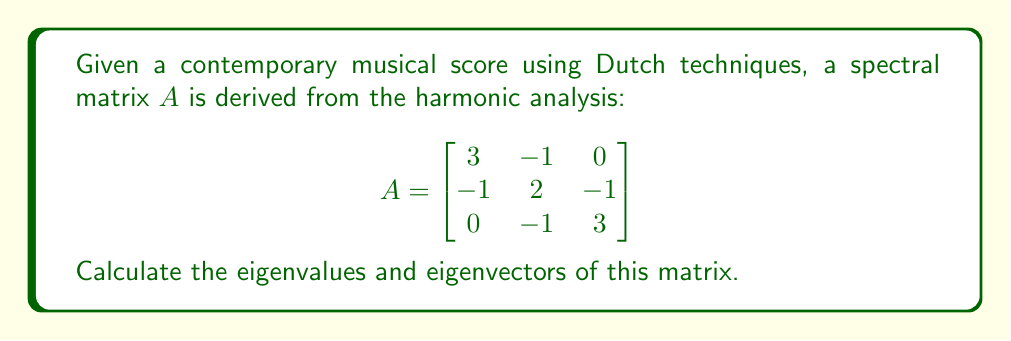Give your solution to this math problem. To find the eigenvalues and eigenvectors of matrix $A$, we follow these steps:

1. Find the characteristic equation:
   $det(A - \lambda I) = 0$
   
   $$\begin{vmatrix}
   3-\lambda & -1 & 0 \\
   -1 & 2-\lambda & -1 \\
   0 & -1 & 3-\lambda
   \end{vmatrix} = 0$$

2. Expand the determinant:
   $(3-\lambda)[(2-\lambda)(3-\lambda) - 1] + (-1)[(-1)(3-\lambda) - 0] = 0$
   $(3-\lambda)[(6-5\lambda+\lambda^2) - 1] - (3-\lambda) = 0$
   $(3-\lambda)(5-5\lambda+\lambda^2) - (3-\lambda) = 0$
   $15-15\lambda+3\lambda^2-5\lambda+5\lambda^2-\lambda^3 - 3 + \lambda = 0$
   $-\lambda^3 + 8\lambda^2 - 19\lambda + 12 = 0$

3. Factor the characteristic equation:
   $(\lambda - 1)(\lambda - 2)(\lambda - 4) = 0$

4. Solve for eigenvalues:
   $\lambda_1 = 1$, $\lambda_2 = 2$, $\lambda_3 = 4$

5. Find eigenvectors for each eigenvalue:
   For $\lambda_1 = 1$:
   $(A - I)v = 0$
   $$\begin{bmatrix}
   2 & -1 & 0 \\
   -1 & 1 & -1 \\
   0 & -1 & 2
   \end{bmatrix}v = 0$$
   Solving this system gives $v_1 = (1, 1, 1)^T$

   For $\lambda_2 = 2$:
   $(A - 2I)v = 0$
   $$\begin{bmatrix}
   1 & -1 & 0 \\
   -1 & 0 & -1 \\
   0 & -1 & 1
   \end{bmatrix}v = 0$$
   Solving this system gives $v_2 = (1, 0, -1)^T$

   For $\lambda_3 = 4$:
   $(A - 4I)v = 0$
   $$\begin{bmatrix}
   -1 & -1 & 0 \\
   -1 & -2 & -1 \\
   0 & -1 & -1
   \end{bmatrix}v = 0$$
   Solving this system gives $v_3 = (1, -2, 1)^T$
Answer: Eigenvalues: $\lambda_1 = 1$, $\lambda_2 = 2$, $\lambda_3 = 4$
Eigenvectors: $v_1 = (1, 1, 1)^T$, $v_2 = (1, 0, -1)^T$, $v_3 = (1, -2, 1)^T$ 